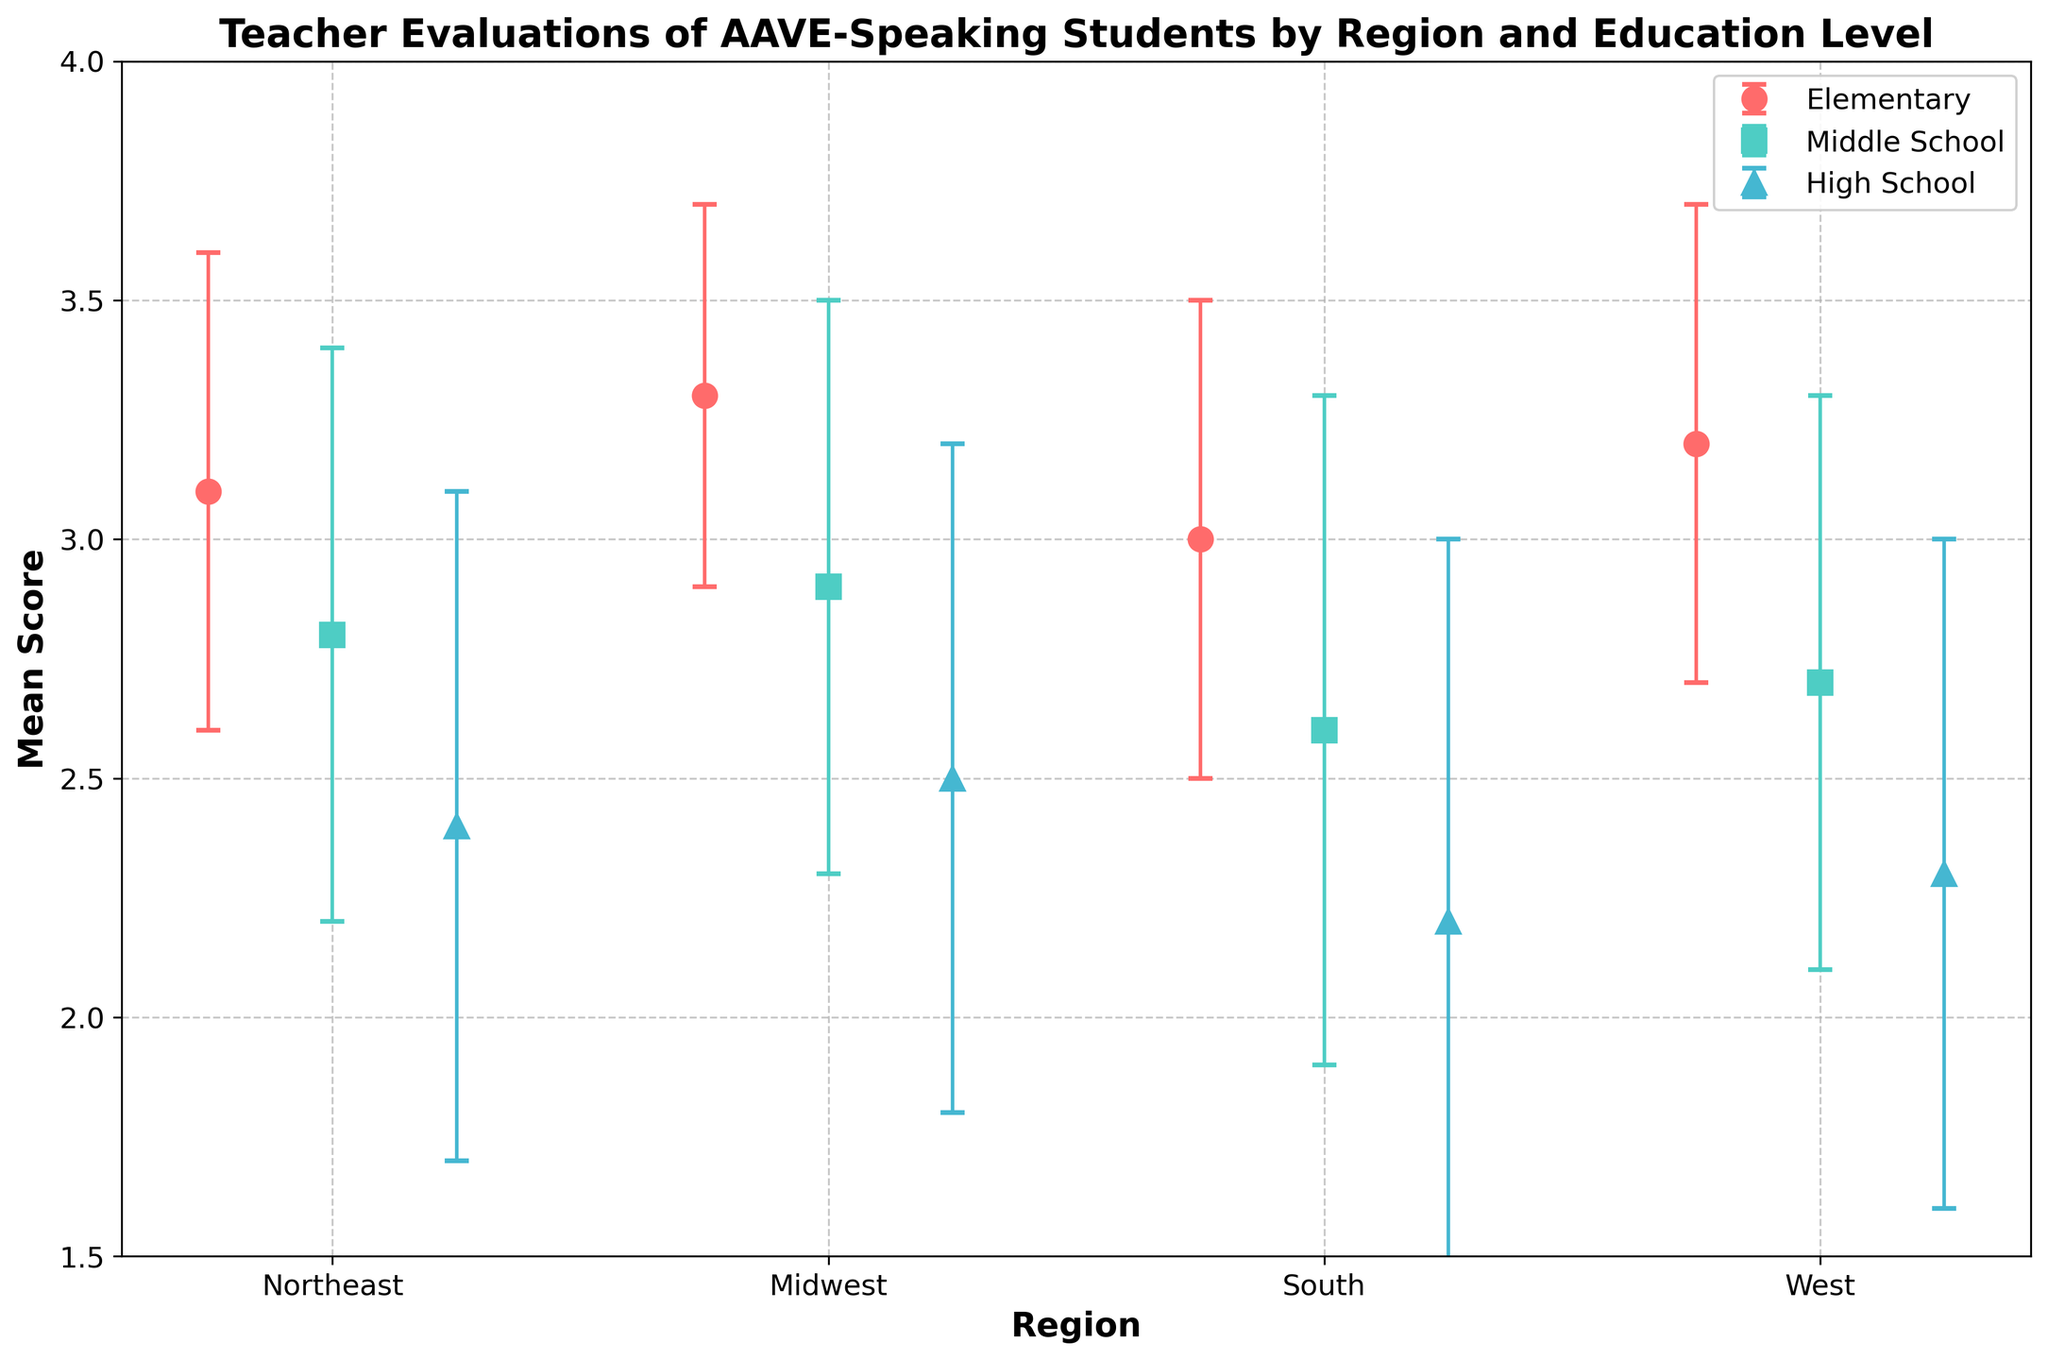What does the title of the figure say? The title can be found at the top of the figure and typically summarizes what the plot is about. In this case, it states "Teacher Evaluations of AAVE-Speaking Students by Region and Education Level".
Answer: Teacher Evaluations of AAVE-Speaking Students by Region and Education Level How many regions are represented in the plot? This can be determined by counting the unique labels on the x-axis. There are four regions named: Northeast, Midwest, South, and West.
Answer: 4 Which education level has the highest mean score in the Midwest? First, find the mean scores for all education levels in the Midwest. Then identify the maximum score among them. Elementary has a mean score of 3.3, Middle School has 2.9, and High School has 2.5.
Answer: Elementary What is the mean score difference between Elementary and High School levels in the South? Locate the mean scores for Elementary (3.0) and High School (2.2) in the South, then subtract the High School score from the Elementary score: 3.0 - 2.2 = 0.8.
Answer: 0.8 Among all regions, which education level shows the most significant variation in teacher evaluations? The most significant variation corresponds to the largest error bar. High School in the South has the largest standard deviation (0.8), so it also likely represents the most variation.
Answer: High School in the South What is the mean score for Middle School in the West? Find the data point corresponding to Middle School in the West region. The mean score listed is 2.7.
Answer: 2.7 How does the mean score for Elementary in the West compare to Elementary in the Northeast? Locate the mean score for Elementary in both regions (West: 3.2, Northeast: 3.1) and compare them. Since 3.2 is greater than 3.1, Elementary in the West has a slightly higher mean score.
Answer: West is higher Which region shows the smallest range of mean scores across all education levels? Calculate the range (difference between the highest and lowest mean scores) for each region. Northeast: 3.1 - 2.4 = 0.7, Midwest: 3.3 - 2.5 = 0.8, South: 3.0 - 2.2 = 0.8, West: 3.2 - 2.3 = 0.9. The Northeast has the smallest range.
Answer: Northeast What is the highest mean score reported for any education level across all regions? Identify the maximum mean score from all the data points. Elementary in the Midwest has the highest score of 3.3.
Answer: 3.3 